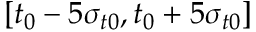Convert formula to latex. <formula><loc_0><loc_0><loc_500><loc_500>[ t _ { 0 } - 5 \sigma _ { t 0 } , t _ { 0 } + 5 \sigma _ { t 0 } ]</formula> 